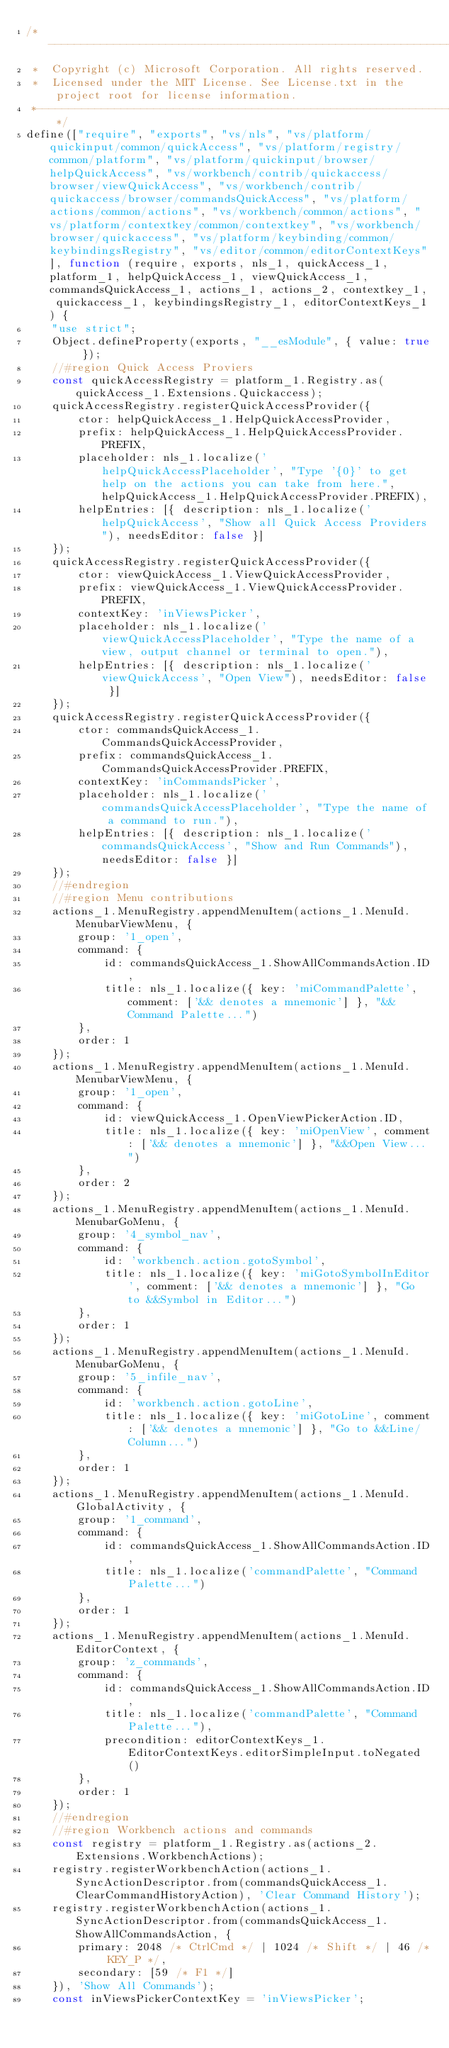<code> <loc_0><loc_0><loc_500><loc_500><_JavaScript_>/*---------------------------------------------------------------------------------------------
 *  Copyright (c) Microsoft Corporation. All rights reserved.
 *  Licensed under the MIT License. See License.txt in the project root for license information.
 *--------------------------------------------------------------------------------------------*/
define(["require", "exports", "vs/nls", "vs/platform/quickinput/common/quickAccess", "vs/platform/registry/common/platform", "vs/platform/quickinput/browser/helpQuickAccess", "vs/workbench/contrib/quickaccess/browser/viewQuickAccess", "vs/workbench/contrib/quickaccess/browser/commandsQuickAccess", "vs/platform/actions/common/actions", "vs/workbench/common/actions", "vs/platform/contextkey/common/contextkey", "vs/workbench/browser/quickaccess", "vs/platform/keybinding/common/keybindingsRegistry", "vs/editor/common/editorContextKeys"], function (require, exports, nls_1, quickAccess_1, platform_1, helpQuickAccess_1, viewQuickAccess_1, commandsQuickAccess_1, actions_1, actions_2, contextkey_1, quickaccess_1, keybindingsRegistry_1, editorContextKeys_1) {
    "use strict";
    Object.defineProperty(exports, "__esModule", { value: true });
    //#region Quick Access Proviers
    const quickAccessRegistry = platform_1.Registry.as(quickAccess_1.Extensions.Quickaccess);
    quickAccessRegistry.registerQuickAccessProvider({
        ctor: helpQuickAccess_1.HelpQuickAccessProvider,
        prefix: helpQuickAccess_1.HelpQuickAccessProvider.PREFIX,
        placeholder: nls_1.localize('helpQuickAccessPlaceholder', "Type '{0}' to get help on the actions you can take from here.", helpQuickAccess_1.HelpQuickAccessProvider.PREFIX),
        helpEntries: [{ description: nls_1.localize('helpQuickAccess', "Show all Quick Access Providers"), needsEditor: false }]
    });
    quickAccessRegistry.registerQuickAccessProvider({
        ctor: viewQuickAccess_1.ViewQuickAccessProvider,
        prefix: viewQuickAccess_1.ViewQuickAccessProvider.PREFIX,
        contextKey: 'inViewsPicker',
        placeholder: nls_1.localize('viewQuickAccessPlaceholder', "Type the name of a view, output channel or terminal to open."),
        helpEntries: [{ description: nls_1.localize('viewQuickAccess', "Open View"), needsEditor: false }]
    });
    quickAccessRegistry.registerQuickAccessProvider({
        ctor: commandsQuickAccess_1.CommandsQuickAccessProvider,
        prefix: commandsQuickAccess_1.CommandsQuickAccessProvider.PREFIX,
        contextKey: 'inCommandsPicker',
        placeholder: nls_1.localize('commandsQuickAccessPlaceholder', "Type the name of a command to run."),
        helpEntries: [{ description: nls_1.localize('commandsQuickAccess', "Show and Run Commands"), needsEditor: false }]
    });
    //#endregion
    //#region Menu contributions
    actions_1.MenuRegistry.appendMenuItem(actions_1.MenuId.MenubarViewMenu, {
        group: '1_open',
        command: {
            id: commandsQuickAccess_1.ShowAllCommandsAction.ID,
            title: nls_1.localize({ key: 'miCommandPalette', comment: ['&& denotes a mnemonic'] }, "&&Command Palette...")
        },
        order: 1
    });
    actions_1.MenuRegistry.appendMenuItem(actions_1.MenuId.MenubarViewMenu, {
        group: '1_open',
        command: {
            id: viewQuickAccess_1.OpenViewPickerAction.ID,
            title: nls_1.localize({ key: 'miOpenView', comment: ['&& denotes a mnemonic'] }, "&&Open View...")
        },
        order: 2
    });
    actions_1.MenuRegistry.appendMenuItem(actions_1.MenuId.MenubarGoMenu, {
        group: '4_symbol_nav',
        command: {
            id: 'workbench.action.gotoSymbol',
            title: nls_1.localize({ key: 'miGotoSymbolInEditor', comment: ['&& denotes a mnemonic'] }, "Go to &&Symbol in Editor...")
        },
        order: 1
    });
    actions_1.MenuRegistry.appendMenuItem(actions_1.MenuId.MenubarGoMenu, {
        group: '5_infile_nav',
        command: {
            id: 'workbench.action.gotoLine',
            title: nls_1.localize({ key: 'miGotoLine', comment: ['&& denotes a mnemonic'] }, "Go to &&Line/Column...")
        },
        order: 1
    });
    actions_1.MenuRegistry.appendMenuItem(actions_1.MenuId.GlobalActivity, {
        group: '1_command',
        command: {
            id: commandsQuickAccess_1.ShowAllCommandsAction.ID,
            title: nls_1.localize('commandPalette', "Command Palette...")
        },
        order: 1
    });
    actions_1.MenuRegistry.appendMenuItem(actions_1.MenuId.EditorContext, {
        group: 'z_commands',
        command: {
            id: commandsQuickAccess_1.ShowAllCommandsAction.ID,
            title: nls_1.localize('commandPalette', "Command Palette..."),
            precondition: editorContextKeys_1.EditorContextKeys.editorSimpleInput.toNegated()
        },
        order: 1
    });
    //#endregion
    //#region Workbench actions and commands
    const registry = platform_1.Registry.as(actions_2.Extensions.WorkbenchActions);
    registry.registerWorkbenchAction(actions_1.SyncActionDescriptor.from(commandsQuickAccess_1.ClearCommandHistoryAction), 'Clear Command History');
    registry.registerWorkbenchAction(actions_1.SyncActionDescriptor.from(commandsQuickAccess_1.ShowAllCommandsAction, {
        primary: 2048 /* CtrlCmd */ | 1024 /* Shift */ | 46 /* KEY_P */,
        secondary: [59 /* F1 */]
    }), 'Show All Commands');
    const inViewsPickerContextKey = 'inViewsPicker';</code> 